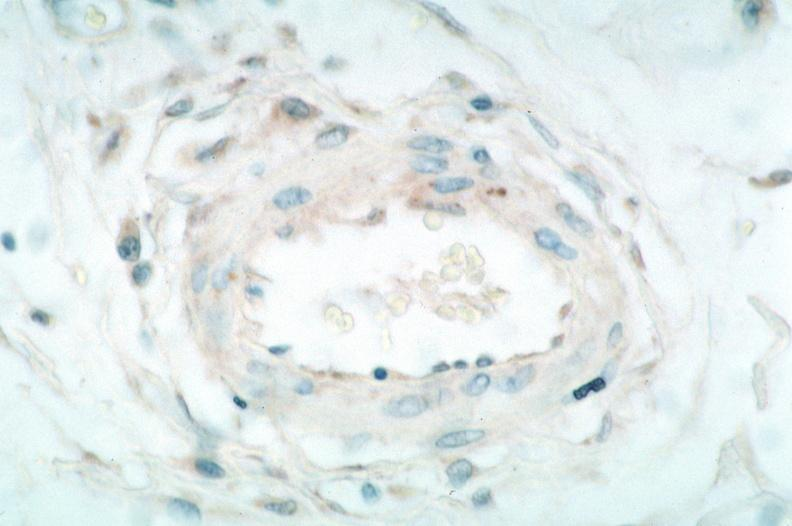s chest and abdomen slide present?
Answer the question using a single word or phrase. No 